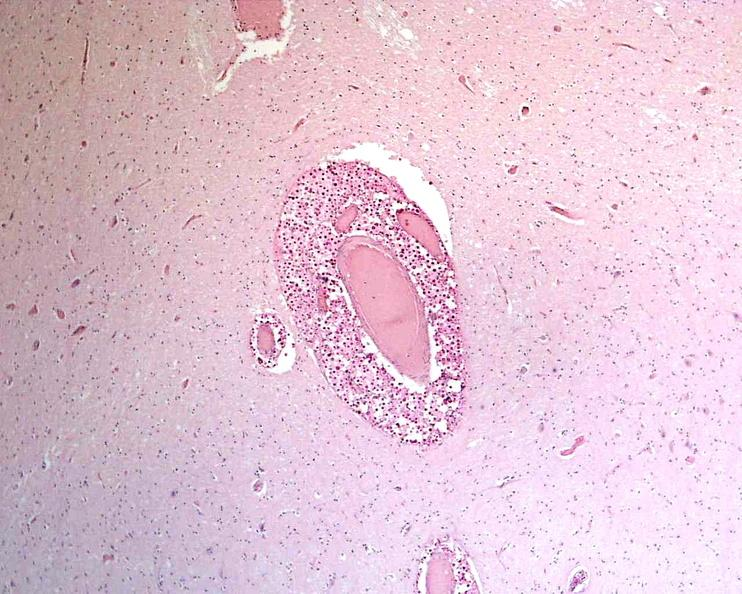does this image show brain, cryptococcal meningitis?
Answer the question using a single word or phrase. Yes 